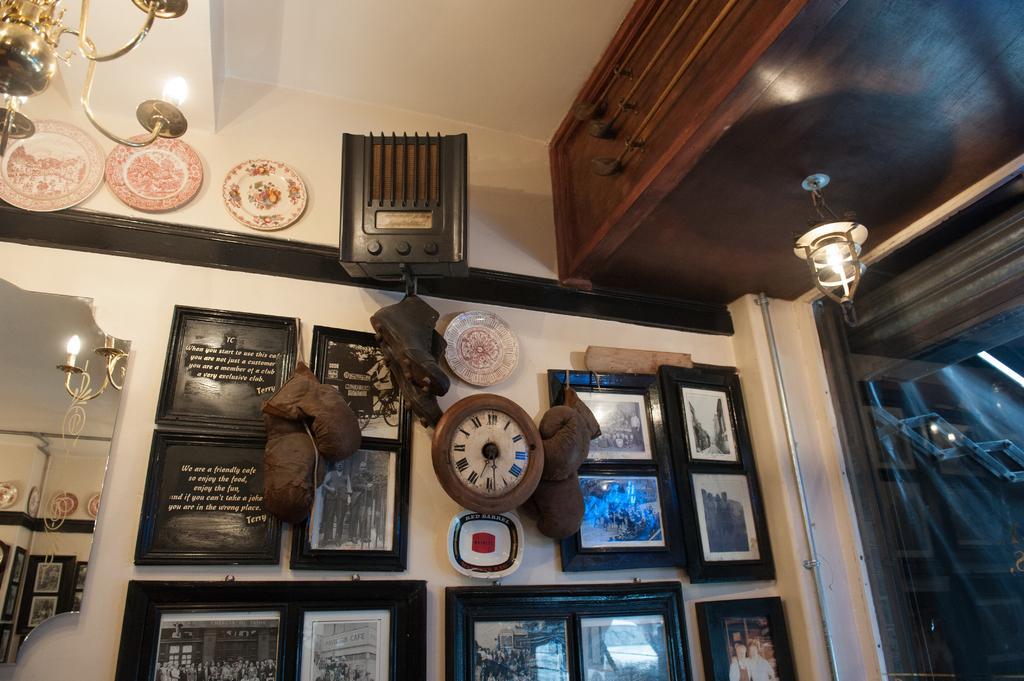Could you give a brief overview of what you see in this image? In the image we can see the internal view of the room. Here we can see frames and clock stick to the wall. Here we can see chandelier, glass wall and wooden furniture. 